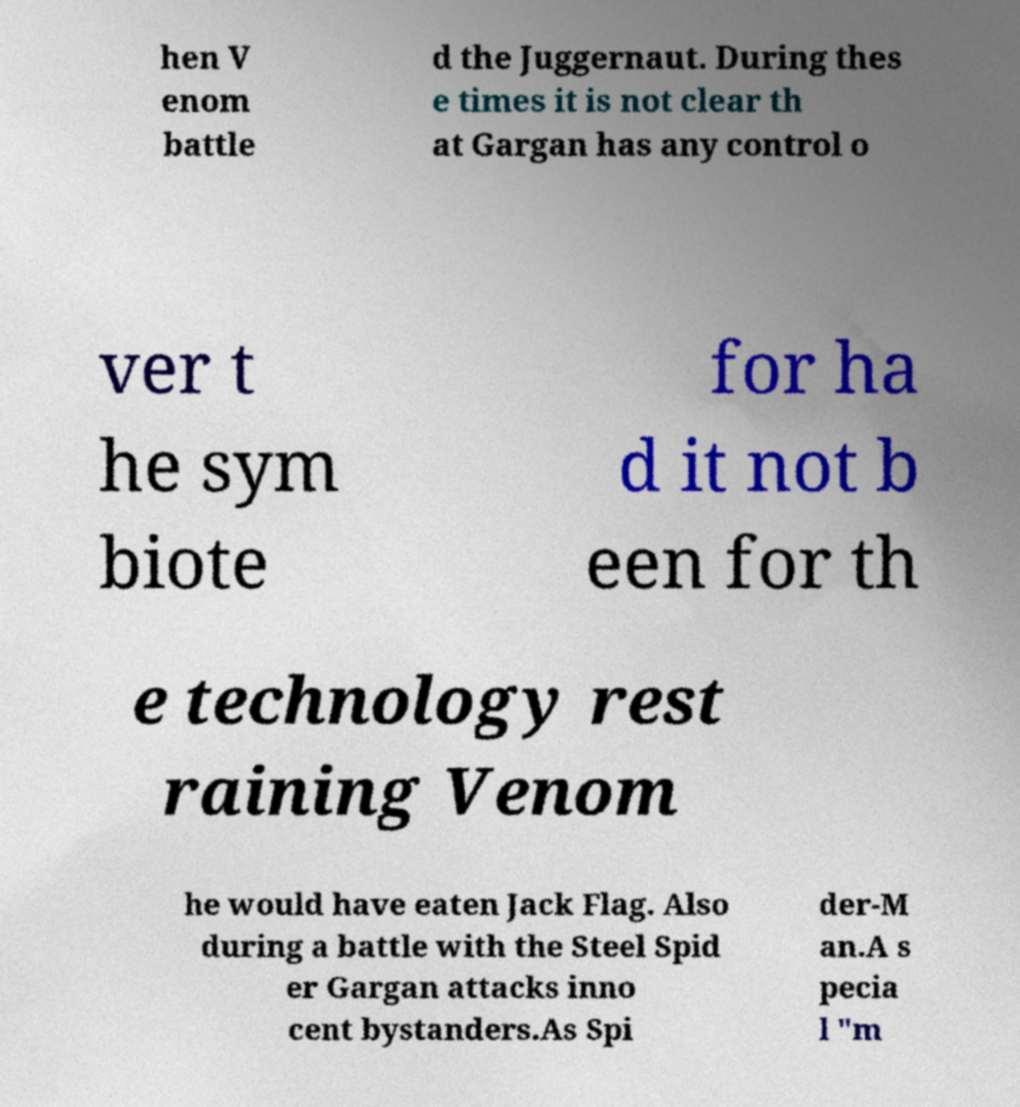Can you accurately transcribe the text from the provided image for me? hen V enom battle d the Juggernaut. During thes e times it is not clear th at Gargan has any control o ver t he sym biote for ha d it not b een for th e technology rest raining Venom he would have eaten Jack Flag. Also during a battle with the Steel Spid er Gargan attacks inno cent bystanders.As Spi der-M an.A s pecia l "m 